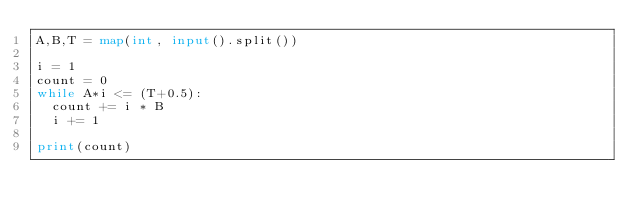Convert code to text. <code><loc_0><loc_0><loc_500><loc_500><_Python_>A,B,T = map(int, input().split())

i = 1
count = 0
while A*i <= (T+0.5):
  count += i * B
  i += 1
  
print(count)</code> 